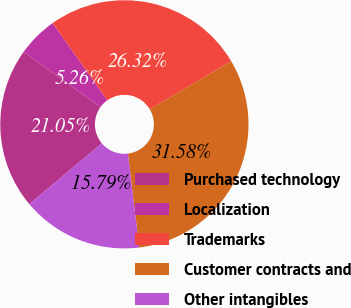Convert chart to OTSL. <chart><loc_0><loc_0><loc_500><loc_500><pie_chart><fcel>Purchased technology<fcel>Localization<fcel>Trademarks<fcel>Customer contracts and<fcel>Other intangibles<nl><fcel>21.05%<fcel>5.26%<fcel>26.32%<fcel>31.58%<fcel>15.79%<nl></chart> 